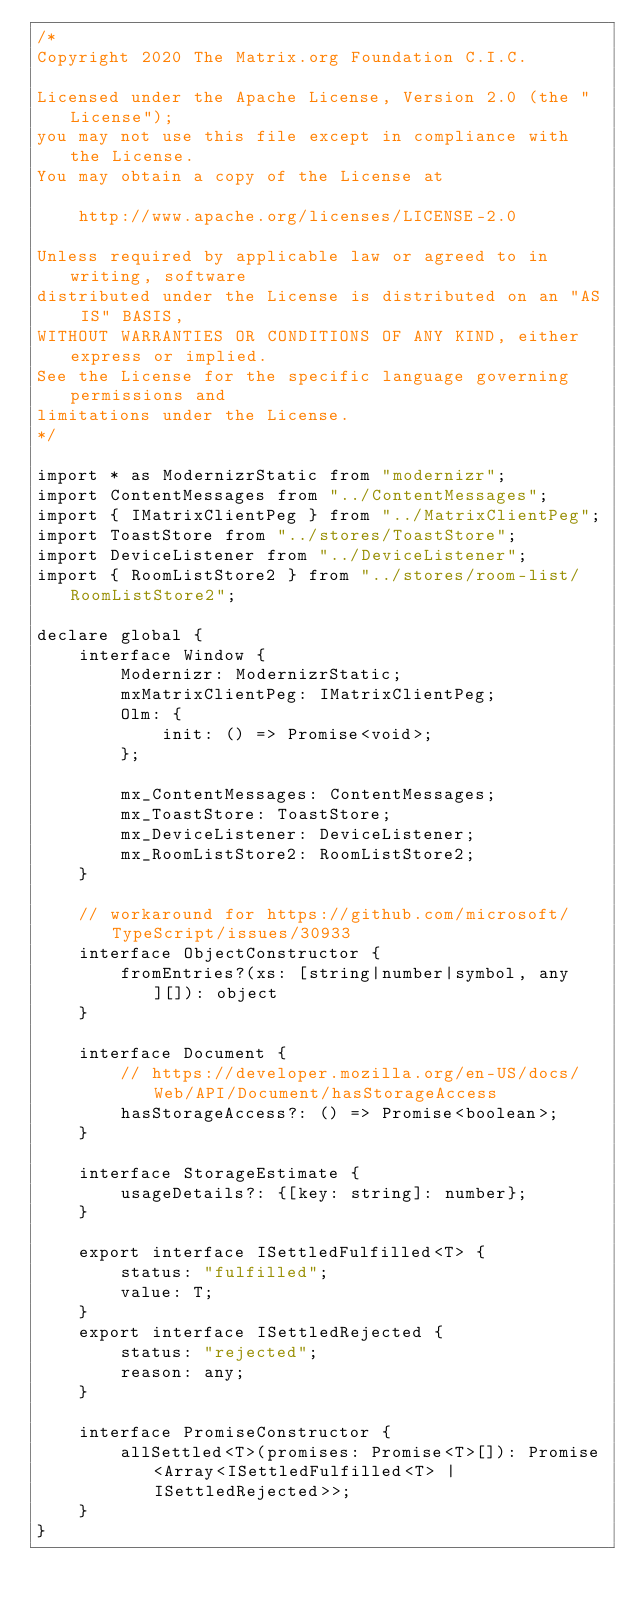<code> <loc_0><loc_0><loc_500><loc_500><_TypeScript_>/*
Copyright 2020 The Matrix.org Foundation C.I.C.

Licensed under the Apache License, Version 2.0 (the "License");
you may not use this file except in compliance with the License.
You may obtain a copy of the License at

    http://www.apache.org/licenses/LICENSE-2.0

Unless required by applicable law or agreed to in writing, software
distributed under the License is distributed on an "AS IS" BASIS,
WITHOUT WARRANTIES OR CONDITIONS OF ANY KIND, either express or implied.
See the License for the specific language governing permissions and
limitations under the License.
*/

import * as ModernizrStatic from "modernizr";
import ContentMessages from "../ContentMessages";
import { IMatrixClientPeg } from "../MatrixClientPeg";
import ToastStore from "../stores/ToastStore";
import DeviceListener from "../DeviceListener";
import { RoomListStore2 } from "../stores/room-list/RoomListStore2";

declare global {
    interface Window {
        Modernizr: ModernizrStatic;
        mxMatrixClientPeg: IMatrixClientPeg;
        Olm: {
            init: () => Promise<void>;
        };

        mx_ContentMessages: ContentMessages;
        mx_ToastStore: ToastStore;
        mx_DeviceListener: DeviceListener;
        mx_RoomListStore2: RoomListStore2;
    }

    // workaround for https://github.com/microsoft/TypeScript/issues/30933
    interface ObjectConstructor {
        fromEntries?(xs: [string|number|symbol, any][]): object
    }

    interface Document {
        // https://developer.mozilla.org/en-US/docs/Web/API/Document/hasStorageAccess
        hasStorageAccess?: () => Promise<boolean>;
    }

    interface StorageEstimate {
        usageDetails?: {[key: string]: number};
    }

    export interface ISettledFulfilled<T> {
        status: "fulfilled";
        value: T;
    }
    export interface ISettledRejected {
        status: "rejected";
        reason: any;
    }

    interface PromiseConstructor {
        allSettled<T>(promises: Promise<T>[]): Promise<Array<ISettledFulfilled<T> | ISettledRejected>>;
    }
}
</code> 